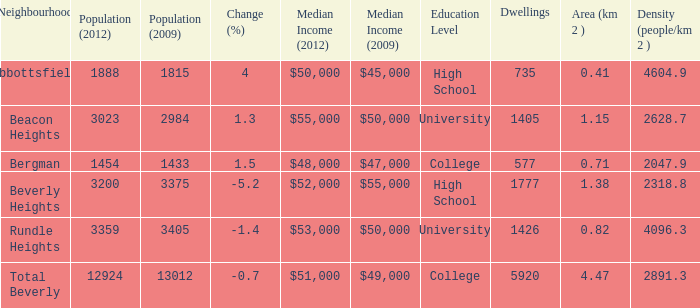What is the density of an area that is 1.38km and has a population more than 12924? 0.0. 